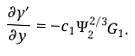<formula> <loc_0><loc_0><loc_500><loc_500>\frac { \partial \gamma ^ { \prime } } { \partial y } = - c _ { 1 } \Psi _ { 2 } ^ { 2 / 3 } G _ { 1 } .</formula> 